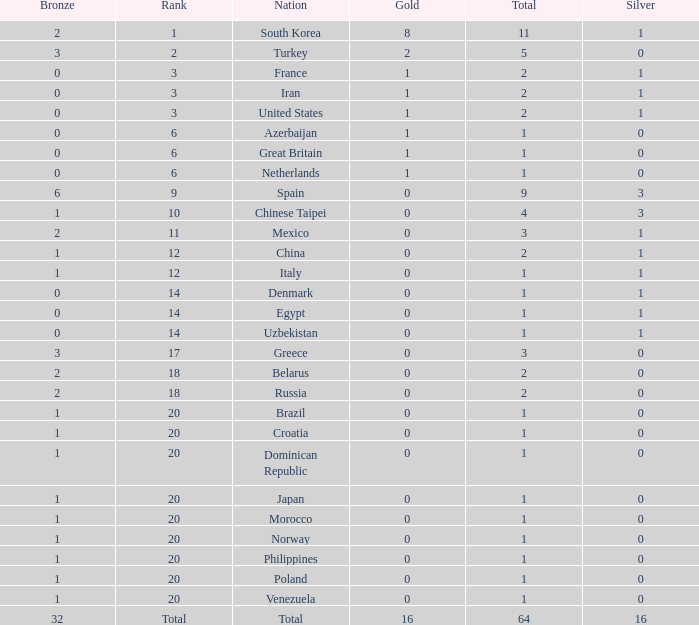How many total silvers does Russia have? 1.0. 